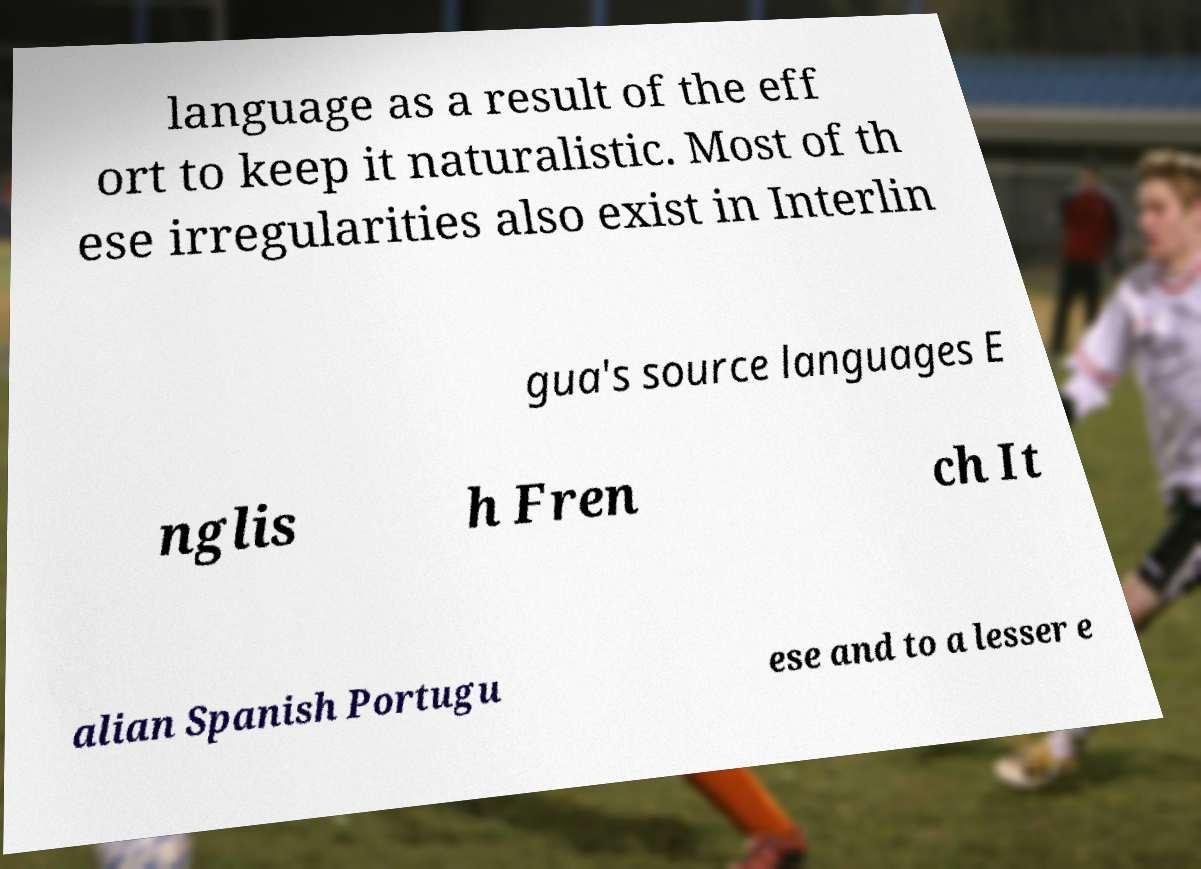Can you read and provide the text displayed in the image?This photo seems to have some interesting text. Can you extract and type it out for me? language as a result of the eff ort to keep it naturalistic. Most of th ese irregularities also exist in Interlin gua's source languages E nglis h Fren ch It alian Spanish Portugu ese and to a lesser e 